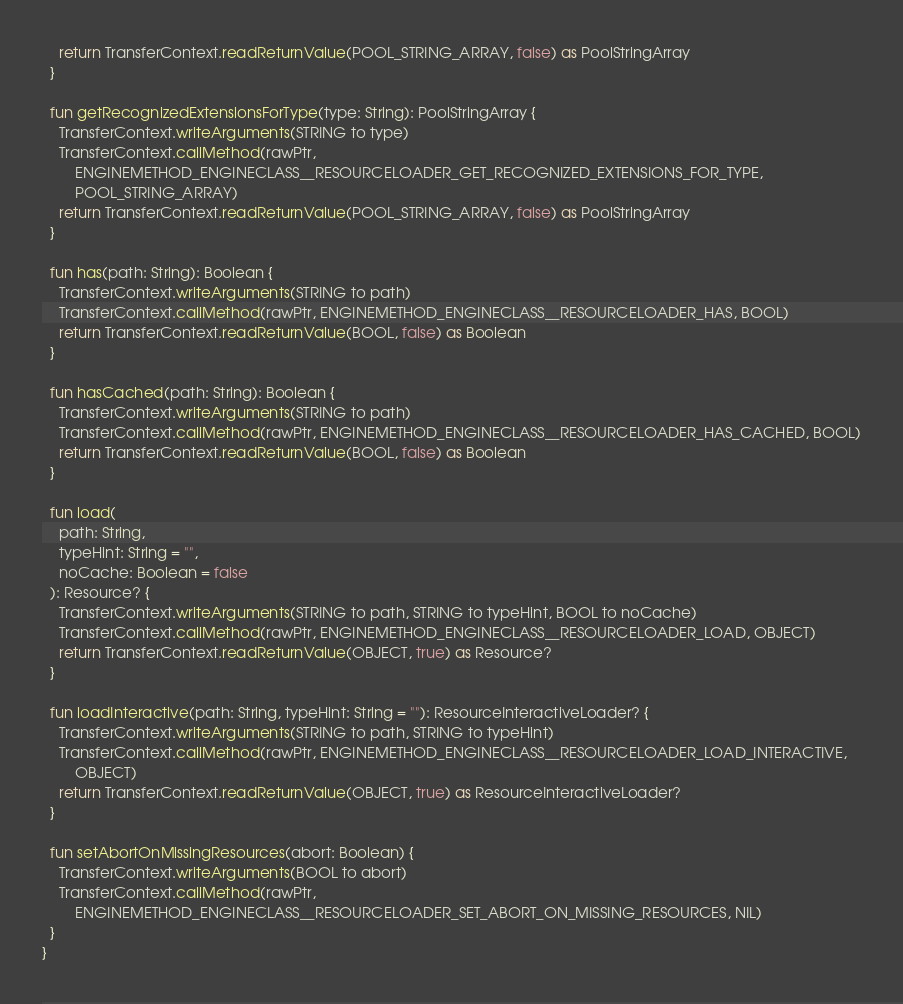<code> <loc_0><loc_0><loc_500><loc_500><_Kotlin_>    return TransferContext.readReturnValue(POOL_STRING_ARRAY, false) as PoolStringArray
  }

  fun getRecognizedExtensionsForType(type: String): PoolStringArray {
    TransferContext.writeArguments(STRING to type)
    TransferContext.callMethod(rawPtr,
        ENGINEMETHOD_ENGINECLASS__RESOURCELOADER_GET_RECOGNIZED_EXTENSIONS_FOR_TYPE,
        POOL_STRING_ARRAY)
    return TransferContext.readReturnValue(POOL_STRING_ARRAY, false) as PoolStringArray
  }

  fun has(path: String): Boolean {
    TransferContext.writeArguments(STRING to path)
    TransferContext.callMethod(rawPtr, ENGINEMETHOD_ENGINECLASS__RESOURCELOADER_HAS, BOOL)
    return TransferContext.readReturnValue(BOOL, false) as Boolean
  }

  fun hasCached(path: String): Boolean {
    TransferContext.writeArguments(STRING to path)
    TransferContext.callMethod(rawPtr, ENGINEMETHOD_ENGINECLASS__RESOURCELOADER_HAS_CACHED, BOOL)
    return TransferContext.readReturnValue(BOOL, false) as Boolean
  }

  fun load(
    path: String,
    typeHint: String = "",
    noCache: Boolean = false
  ): Resource? {
    TransferContext.writeArguments(STRING to path, STRING to typeHint, BOOL to noCache)
    TransferContext.callMethod(rawPtr, ENGINEMETHOD_ENGINECLASS__RESOURCELOADER_LOAD, OBJECT)
    return TransferContext.readReturnValue(OBJECT, true) as Resource?
  }

  fun loadInteractive(path: String, typeHint: String = ""): ResourceInteractiveLoader? {
    TransferContext.writeArguments(STRING to path, STRING to typeHint)
    TransferContext.callMethod(rawPtr, ENGINEMETHOD_ENGINECLASS__RESOURCELOADER_LOAD_INTERACTIVE,
        OBJECT)
    return TransferContext.readReturnValue(OBJECT, true) as ResourceInteractiveLoader?
  }

  fun setAbortOnMissingResources(abort: Boolean) {
    TransferContext.writeArguments(BOOL to abort)
    TransferContext.callMethod(rawPtr,
        ENGINEMETHOD_ENGINECLASS__RESOURCELOADER_SET_ABORT_ON_MISSING_RESOURCES, NIL)
  }
}
</code> 